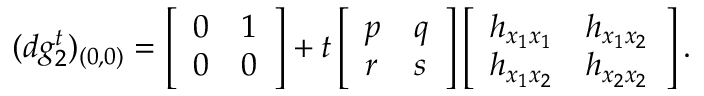<formula> <loc_0><loc_0><loc_500><loc_500>( d g _ { 2 } ^ { t } ) _ { ( 0 , 0 ) } = \left [ \begin{array} { l l } { 0 } & { 1 } \\ { 0 } & { 0 } \end{array} \right ] + t \left [ \begin{array} { l l } { p } & { q } \\ { r } & { s } \end{array} \right ] \left [ \begin{array} { l l } { h _ { x _ { 1 } x _ { 1 } } } & { h _ { x _ { 1 } x _ { 2 } } } \\ { h _ { x _ { 1 } x _ { 2 } } } & { h _ { x _ { 2 } x _ { 2 } } } \end{array} \right ] .</formula> 